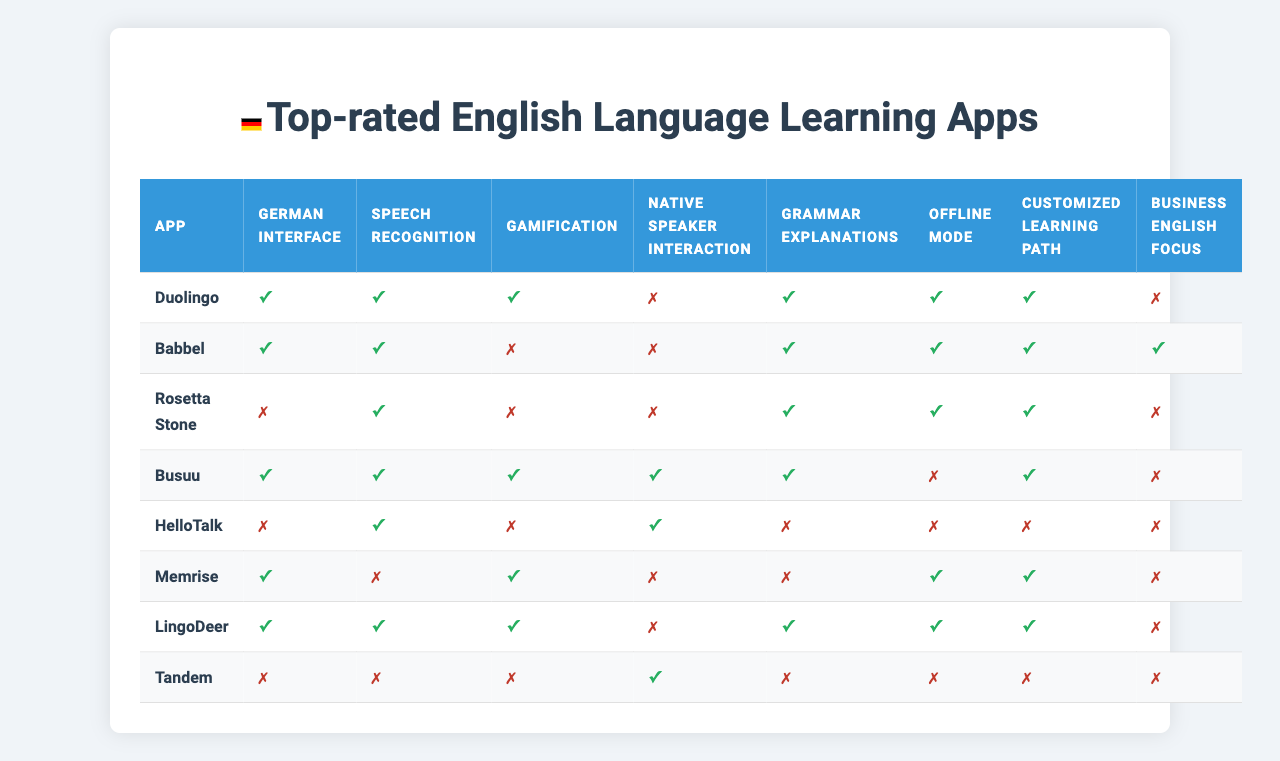What English language learning app offers a German interface? The table lists the features of each app, and Duolingo has a '1' under the 'German interface' column, indicating that it offers this feature.
Answer: Duolingo Which app focuses on Business English? In the table, only Babbel has a '1' under the 'Business English focus' column, which indicates it offers targeted learning for Business English.
Answer: Babbel Does Rosetta Stone have offline mode? Looking at the table, Rosetta Stone has a '0' under the 'Offline mode' column, meaning it does not offer this feature.
Answer: No How many apps provide a native speaker interaction feature? By counting the '1's in the 'Native speaker interaction' column, we find that three apps—Babbel, HelloTalk, and Tandem—offer this feature, as they all have '1' in that column.
Answer: Three Which app has the most features available? If we count the number of '1's for each app: Duolingo has 6, Babbel has 5, Rosetta Stone has 5, Busuu has 6, HelloTalk has 1, Memrise has 5, LingoDeer has 6, and Tandem has 1. The maximum is 6 features, found in Duolingo, Busuu, and LingoDeer.
Answer: Duolingo, Busuu, LingoDeer Is there any app that offers all eight features? By examining the data in the table, we find that no app has a '1' in all columns, as the maximum count is 6 features available for specific apps.
Answer: No What fraction of the apps provide speech recognition? The table indicates that speech recognition is available in four apps: Babbel, Memrise, LingoDeer, and Busuu, out of a total of eight apps. Calculating the fraction gives us 4/8, which simplifies to 1/2.
Answer: 1/2 Which app has the least features and what are they? Tandem has only two features available (1 for 'Native speaker interaction' and 0 for all others), making it the app with the least features. Therefore, it offers very limited functionalities compared to others.
Answer: Tandem; Native speaker interaction only How many apps offer both grammar explanations and offline mode? Searching through the table specifically for applications that have a '1' in both the 'Grammar explanations' and 'Offline mode' columns reveals that only one app, Memrise, fits this criterion.
Answer: One (Memrise) Which app features gamification and what other features does it have? Looking at the table, Duolingo and Busuu both have '1' for gamification. Duolingo has a total of 6 features (including gamification), while Busuu also has 6 features.
Answer: Duolingo and Busuu; they each have 6 features 